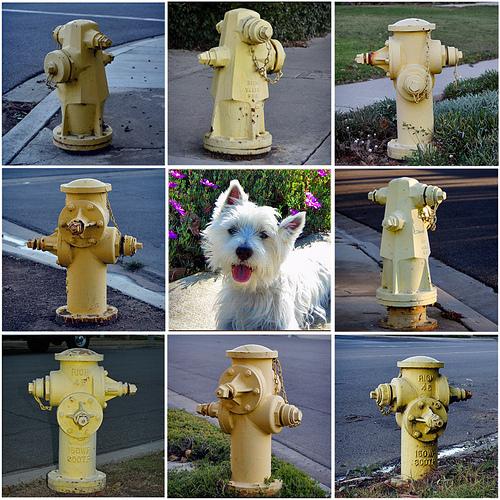Is one of these things different from the others?
Give a very brief answer. Yes. Are all of them yellow fire hydrants?
Be succinct. No. Which fire hydrant is most common?
Be succinct. Yellow one. 